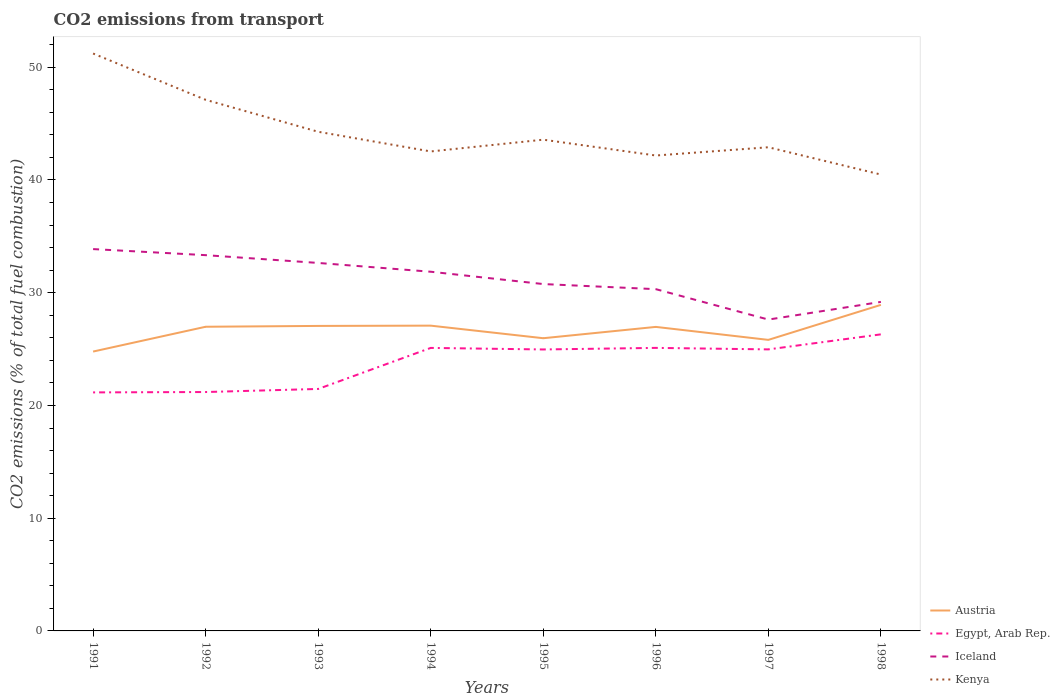Does the line corresponding to Austria intersect with the line corresponding to Iceland?
Offer a terse response. No. Across all years, what is the maximum total CO2 emitted in Austria?
Offer a very short reply. 24.78. In which year was the total CO2 emitted in Egypt, Arab Rep. maximum?
Your response must be concise. 1991. What is the total total CO2 emitted in Kenya in the graph?
Give a very brief answer. -0.73. What is the difference between the highest and the second highest total CO2 emitted in Egypt, Arab Rep.?
Offer a terse response. 5.15. What is the difference between the highest and the lowest total CO2 emitted in Egypt, Arab Rep.?
Ensure brevity in your answer.  5. Are the values on the major ticks of Y-axis written in scientific E-notation?
Your response must be concise. No. Does the graph contain grids?
Your response must be concise. No. Where does the legend appear in the graph?
Your answer should be compact. Bottom right. How many legend labels are there?
Your answer should be very brief. 4. How are the legend labels stacked?
Make the answer very short. Vertical. What is the title of the graph?
Provide a short and direct response. CO2 emissions from transport. What is the label or title of the X-axis?
Give a very brief answer. Years. What is the label or title of the Y-axis?
Your answer should be very brief. CO2 emissions (% of total fuel combustion). What is the CO2 emissions (% of total fuel combustion) in Austria in 1991?
Offer a very short reply. 24.78. What is the CO2 emissions (% of total fuel combustion) in Egypt, Arab Rep. in 1991?
Offer a very short reply. 21.16. What is the CO2 emissions (% of total fuel combustion) of Iceland in 1991?
Your answer should be very brief. 33.87. What is the CO2 emissions (% of total fuel combustion) in Kenya in 1991?
Provide a succinct answer. 51.22. What is the CO2 emissions (% of total fuel combustion) of Austria in 1992?
Your response must be concise. 26.98. What is the CO2 emissions (% of total fuel combustion) in Egypt, Arab Rep. in 1992?
Give a very brief answer. 21.19. What is the CO2 emissions (% of total fuel combustion) of Iceland in 1992?
Your answer should be compact. 33.33. What is the CO2 emissions (% of total fuel combustion) of Kenya in 1992?
Provide a short and direct response. 47.11. What is the CO2 emissions (% of total fuel combustion) of Austria in 1993?
Ensure brevity in your answer.  27.06. What is the CO2 emissions (% of total fuel combustion) in Egypt, Arab Rep. in 1993?
Provide a succinct answer. 21.46. What is the CO2 emissions (% of total fuel combustion) of Iceland in 1993?
Provide a succinct answer. 32.64. What is the CO2 emissions (% of total fuel combustion) of Kenya in 1993?
Give a very brief answer. 44.28. What is the CO2 emissions (% of total fuel combustion) in Austria in 1994?
Offer a terse response. 27.08. What is the CO2 emissions (% of total fuel combustion) in Egypt, Arab Rep. in 1994?
Provide a succinct answer. 25.1. What is the CO2 emissions (% of total fuel combustion) of Iceland in 1994?
Offer a very short reply. 31.86. What is the CO2 emissions (% of total fuel combustion) in Kenya in 1994?
Provide a succinct answer. 42.53. What is the CO2 emissions (% of total fuel combustion) of Austria in 1995?
Offer a terse response. 25.96. What is the CO2 emissions (% of total fuel combustion) of Egypt, Arab Rep. in 1995?
Offer a very short reply. 24.97. What is the CO2 emissions (% of total fuel combustion) of Iceland in 1995?
Give a very brief answer. 30.77. What is the CO2 emissions (% of total fuel combustion) in Kenya in 1995?
Keep it short and to the point. 43.58. What is the CO2 emissions (% of total fuel combustion) in Austria in 1996?
Provide a succinct answer. 26.97. What is the CO2 emissions (% of total fuel combustion) in Egypt, Arab Rep. in 1996?
Offer a terse response. 25.11. What is the CO2 emissions (% of total fuel combustion) in Iceland in 1996?
Provide a short and direct response. 30.32. What is the CO2 emissions (% of total fuel combustion) of Kenya in 1996?
Give a very brief answer. 42.17. What is the CO2 emissions (% of total fuel combustion) in Austria in 1997?
Provide a short and direct response. 25.82. What is the CO2 emissions (% of total fuel combustion) of Egypt, Arab Rep. in 1997?
Make the answer very short. 24.97. What is the CO2 emissions (% of total fuel combustion) in Iceland in 1997?
Ensure brevity in your answer.  27.62. What is the CO2 emissions (% of total fuel combustion) of Kenya in 1997?
Your answer should be very brief. 42.9. What is the CO2 emissions (% of total fuel combustion) of Austria in 1998?
Make the answer very short. 28.92. What is the CO2 emissions (% of total fuel combustion) of Egypt, Arab Rep. in 1998?
Your response must be concise. 26.31. What is the CO2 emissions (% of total fuel combustion) of Iceland in 1998?
Offer a terse response. 29.19. What is the CO2 emissions (% of total fuel combustion) in Kenya in 1998?
Your answer should be compact. 40.48. Across all years, what is the maximum CO2 emissions (% of total fuel combustion) of Austria?
Provide a short and direct response. 28.92. Across all years, what is the maximum CO2 emissions (% of total fuel combustion) of Egypt, Arab Rep.?
Your answer should be compact. 26.31. Across all years, what is the maximum CO2 emissions (% of total fuel combustion) of Iceland?
Give a very brief answer. 33.87. Across all years, what is the maximum CO2 emissions (% of total fuel combustion) of Kenya?
Give a very brief answer. 51.22. Across all years, what is the minimum CO2 emissions (% of total fuel combustion) of Austria?
Make the answer very short. 24.78. Across all years, what is the minimum CO2 emissions (% of total fuel combustion) in Egypt, Arab Rep.?
Your answer should be compact. 21.16. Across all years, what is the minimum CO2 emissions (% of total fuel combustion) in Iceland?
Offer a terse response. 27.62. Across all years, what is the minimum CO2 emissions (% of total fuel combustion) in Kenya?
Offer a very short reply. 40.48. What is the total CO2 emissions (% of total fuel combustion) in Austria in the graph?
Offer a terse response. 213.57. What is the total CO2 emissions (% of total fuel combustion) of Egypt, Arab Rep. in the graph?
Make the answer very short. 190.28. What is the total CO2 emissions (% of total fuel combustion) in Iceland in the graph?
Ensure brevity in your answer.  249.6. What is the total CO2 emissions (% of total fuel combustion) of Kenya in the graph?
Provide a succinct answer. 354.28. What is the difference between the CO2 emissions (% of total fuel combustion) in Austria in 1991 and that in 1992?
Ensure brevity in your answer.  -2.2. What is the difference between the CO2 emissions (% of total fuel combustion) of Egypt, Arab Rep. in 1991 and that in 1992?
Provide a short and direct response. -0.03. What is the difference between the CO2 emissions (% of total fuel combustion) of Iceland in 1991 and that in 1992?
Give a very brief answer. 0.54. What is the difference between the CO2 emissions (% of total fuel combustion) of Kenya in 1991 and that in 1992?
Ensure brevity in your answer.  4.11. What is the difference between the CO2 emissions (% of total fuel combustion) in Austria in 1991 and that in 1993?
Keep it short and to the point. -2.27. What is the difference between the CO2 emissions (% of total fuel combustion) in Egypt, Arab Rep. in 1991 and that in 1993?
Your answer should be compact. -0.31. What is the difference between the CO2 emissions (% of total fuel combustion) in Iceland in 1991 and that in 1993?
Your answer should be very brief. 1.23. What is the difference between the CO2 emissions (% of total fuel combustion) in Kenya in 1991 and that in 1993?
Keep it short and to the point. 6.94. What is the difference between the CO2 emissions (% of total fuel combustion) of Austria in 1991 and that in 1994?
Keep it short and to the point. -2.3. What is the difference between the CO2 emissions (% of total fuel combustion) of Egypt, Arab Rep. in 1991 and that in 1994?
Make the answer very short. -3.95. What is the difference between the CO2 emissions (% of total fuel combustion) of Iceland in 1991 and that in 1994?
Provide a succinct answer. 2.01. What is the difference between the CO2 emissions (% of total fuel combustion) of Kenya in 1991 and that in 1994?
Give a very brief answer. 8.69. What is the difference between the CO2 emissions (% of total fuel combustion) in Austria in 1991 and that in 1995?
Offer a very short reply. -1.18. What is the difference between the CO2 emissions (% of total fuel combustion) in Egypt, Arab Rep. in 1991 and that in 1995?
Give a very brief answer. -3.81. What is the difference between the CO2 emissions (% of total fuel combustion) of Iceland in 1991 and that in 1995?
Ensure brevity in your answer.  3.1. What is the difference between the CO2 emissions (% of total fuel combustion) in Kenya in 1991 and that in 1995?
Give a very brief answer. 7.64. What is the difference between the CO2 emissions (% of total fuel combustion) of Austria in 1991 and that in 1996?
Give a very brief answer. -2.19. What is the difference between the CO2 emissions (% of total fuel combustion) in Egypt, Arab Rep. in 1991 and that in 1996?
Your answer should be compact. -3.95. What is the difference between the CO2 emissions (% of total fuel combustion) in Iceland in 1991 and that in 1996?
Provide a short and direct response. 3.55. What is the difference between the CO2 emissions (% of total fuel combustion) in Kenya in 1991 and that in 1996?
Offer a terse response. 9.05. What is the difference between the CO2 emissions (% of total fuel combustion) of Austria in 1991 and that in 1997?
Your response must be concise. -1.04. What is the difference between the CO2 emissions (% of total fuel combustion) in Egypt, Arab Rep. in 1991 and that in 1997?
Provide a succinct answer. -3.82. What is the difference between the CO2 emissions (% of total fuel combustion) of Iceland in 1991 and that in 1997?
Your answer should be very brief. 6.25. What is the difference between the CO2 emissions (% of total fuel combustion) of Kenya in 1991 and that in 1997?
Your response must be concise. 8.32. What is the difference between the CO2 emissions (% of total fuel combustion) of Austria in 1991 and that in 1998?
Your answer should be very brief. -4.14. What is the difference between the CO2 emissions (% of total fuel combustion) in Egypt, Arab Rep. in 1991 and that in 1998?
Your answer should be compact. -5.15. What is the difference between the CO2 emissions (% of total fuel combustion) of Iceland in 1991 and that in 1998?
Your answer should be compact. 4.68. What is the difference between the CO2 emissions (% of total fuel combustion) of Kenya in 1991 and that in 1998?
Provide a short and direct response. 10.74. What is the difference between the CO2 emissions (% of total fuel combustion) of Austria in 1992 and that in 1993?
Keep it short and to the point. -0.07. What is the difference between the CO2 emissions (% of total fuel combustion) in Egypt, Arab Rep. in 1992 and that in 1993?
Ensure brevity in your answer.  -0.27. What is the difference between the CO2 emissions (% of total fuel combustion) of Iceland in 1992 and that in 1993?
Your response must be concise. 0.69. What is the difference between the CO2 emissions (% of total fuel combustion) in Kenya in 1992 and that in 1993?
Provide a short and direct response. 2.84. What is the difference between the CO2 emissions (% of total fuel combustion) in Austria in 1992 and that in 1994?
Provide a succinct answer. -0.1. What is the difference between the CO2 emissions (% of total fuel combustion) in Egypt, Arab Rep. in 1992 and that in 1994?
Provide a short and direct response. -3.91. What is the difference between the CO2 emissions (% of total fuel combustion) in Iceland in 1992 and that in 1994?
Offer a very short reply. 1.47. What is the difference between the CO2 emissions (% of total fuel combustion) of Kenya in 1992 and that in 1994?
Your answer should be compact. 4.58. What is the difference between the CO2 emissions (% of total fuel combustion) of Austria in 1992 and that in 1995?
Your response must be concise. 1.02. What is the difference between the CO2 emissions (% of total fuel combustion) in Egypt, Arab Rep. in 1992 and that in 1995?
Offer a very short reply. -3.78. What is the difference between the CO2 emissions (% of total fuel combustion) in Iceland in 1992 and that in 1995?
Ensure brevity in your answer.  2.56. What is the difference between the CO2 emissions (% of total fuel combustion) of Kenya in 1992 and that in 1995?
Make the answer very short. 3.54. What is the difference between the CO2 emissions (% of total fuel combustion) in Austria in 1992 and that in 1996?
Keep it short and to the point. 0.01. What is the difference between the CO2 emissions (% of total fuel combustion) in Egypt, Arab Rep. in 1992 and that in 1996?
Your answer should be compact. -3.92. What is the difference between the CO2 emissions (% of total fuel combustion) of Iceland in 1992 and that in 1996?
Provide a succinct answer. 3.02. What is the difference between the CO2 emissions (% of total fuel combustion) in Kenya in 1992 and that in 1996?
Give a very brief answer. 4.94. What is the difference between the CO2 emissions (% of total fuel combustion) of Austria in 1992 and that in 1997?
Provide a short and direct response. 1.16. What is the difference between the CO2 emissions (% of total fuel combustion) of Egypt, Arab Rep. in 1992 and that in 1997?
Ensure brevity in your answer.  -3.78. What is the difference between the CO2 emissions (% of total fuel combustion) of Iceland in 1992 and that in 1997?
Offer a terse response. 5.71. What is the difference between the CO2 emissions (% of total fuel combustion) of Kenya in 1992 and that in 1997?
Give a very brief answer. 4.21. What is the difference between the CO2 emissions (% of total fuel combustion) of Austria in 1992 and that in 1998?
Your response must be concise. -1.94. What is the difference between the CO2 emissions (% of total fuel combustion) of Egypt, Arab Rep. in 1992 and that in 1998?
Offer a very short reply. -5.12. What is the difference between the CO2 emissions (% of total fuel combustion) in Iceland in 1992 and that in 1998?
Offer a very short reply. 4.15. What is the difference between the CO2 emissions (% of total fuel combustion) in Kenya in 1992 and that in 1998?
Keep it short and to the point. 6.63. What is the difference between the CO2 emissions (% of total fuel combustion) of Austria in 1993 and that in 1994?
Your answer should be compact. -0.03. What is the difference between the CO2 emissions (% of total fuel combustion) in Egypt, Arab Rep. in 1993 and that in 1994?
Make the answer very short. -3.64. What is the difference between the CO2 emissions (% of total fuel combustion) in Iceland in 1993 and that in 1994?
Make the answer very short. 0.78. What is the difference between the CO2 emissions (% of total fuel combustion) of Kenya in 1993 and that in 1994?
Provide a short and direct response. 1.74. What is the difference between the CO2 emissions (% of total fuel combustion) in Austria in 1993 and that in 1995?
Keep it short and to the point. 1.09. What is the difference between the CO2 emissions (% of total fuel combustion) in Egypt, Arab Rep. in 1993 and that in 1995?
Offer a very short reply. -3.5. What is the difference between the CO2 emissions (% of total fuel combustion) in Iceland in 1993 and that in 1995?
Keep it short and to the point. 1.87. What is the difference between the CO2 emissions (% of total fuel combustion) of Kenya in 1993 and that in 1995?
Provide a short and direct response. 0.7. What is the difference between the CO2 emissions (% of total fuel combustion) of Austria in 1993 and that in 1996?
Your answer should be very brief. 0.09. What is the difference between the CO2 emissions (% of total fuel combustion) of Egypt, Arab Rep. in 1993 and that in 1996?
Your answer should be very brief. -3.64. What is the difference between the CO2 emissions (% of total fuel combustion) of Iceland in 1993 and that in 1996?
Keep it short and to the point. 2.33. What is the difference between the CO2 emissions (% of total fuel combustion) in Kenya in 1993 and that in 1996?
Offer a very short reply. 2.11. What is the difference between the CO2 emissions (% of total fuel combustion) of Austria in 1993 and that in 1997?
Your response must be concise. 1.24. What is the difference between the CO2 emissions (% of total fuel combustion) in Egypt, Arab Rep. in 1993 and that in 1997?
Make the answer very short. -3.51. What is the difference between the CO2 emissions (% of total fuel combustion) in Iceland in 1993 and that in 1997?
Keep it short and to the point. 5.02. What is the difference between the CO2 emissions (% of total fuel combustion) in Kenya in 1993 and that in 1997?
Give a very brief answer. 1.37. What is the difference between the CO2 emissions (% of total fuel combustion) of Austria in 1993 and that in 1998?
Give a very brief answer. -1.87. What is the difference between the CO2 emissions (% of total fuel combustion) of Egypt, Arab Rep. in 1993 and that in 1998?
Keep it short and to the point. -4.84. What is the difference between the CO2 emissions (% of total fuel combustion) in Iceland in 1993 and that in 1998?
Keep it short and to the point. 3.46. What is the difference between the CO2 emissions (% of total fuel combustion) of Kenya in 1993 and that in 1998?
Ensure brevity in your answer.  3.79. What is the difference between the CO2 emissions (% of total fuel combustion) in Austria in 1994 and that in 1995?
Offer a terse response. 1.12. What is the difference between the CO2 emissions (% of total fuel combustion) of Egypt, Arab Rep. in 1994 and that in 1995?
Ensure brevity in your answer.  0.14. What is the difference between the CO2 emissions (% of total fuel combustion) of Iceland in 1994 and that in 1995?
Make the answer very short. 1.09. What is the difference between the CO2 emissions (% of total fuel combustion) of Kenya in 1994 and that in 1995?
Offer a very short reply. -1.04. What is the difference between the CO2 emissions (% of total fuel combustion) of Austria in 1994 and that in 1996?
Ensure brevity in your answer.  0.11. What is the difference between the CO2 emissions (% of total fuel combustion) in Egypt, Arab Rep. in 1994 and that in 1996?
Your response must be concise. -0. What is the difference between the CO2 emissions (% of total fuel combustion) in Iceland in 1994 and that in 1996?
Keep it short and to the point. 1.55. What is the difference between the CO2 emissions (% of total fuel combustion) of Kenya in 1994 and that in 1996?
Your answer should be compact. 0.36. What is the difference between the CO2 emissions (% of total fuel combustion) in Austria in 1994 and that in 1997?
Provide a short and direct response. 1.26. What is the difference between the CO2 emissions (% of total fuel combustion) in Egypt, Arab Rep. in 1994 and that in 1997?
Ensure brevity in your answer.  0.13. What is the difference between the CO2 emissions (% of total fuel combustion) in Iceland in 1994 and that in 1997?
Ensure brevity in your answer.  4.24. What is the difference between the CO2 emissions (% of total fuel combustion) in Kenya in 1994 and that in 1997?
Your answer should be very brief. -0.37. What is the difference between the CO2 emissions (% of total fuel combustion) in Austria in 1994 and that in 1998?
Make the answer very short. -1.84. What is the difference between the CO2 emissions (% of total fuel combustion) in Egypt, Arab Rep. in 1994 and that in 1998?
Offer a very short reply. -1.2. What is the difference between the CO2 emissions (% of total fuel combustion) of Iceland in 1994 and that in 1998?
Ensure brevity in your answer.  2.68. What is the difference between the CO2 emissions (% of total fuel combustion) in Kenya in 1994 and that in 1998?
Make the answer very short. 2.05. What is the difference between the CO2 emissions (% of total fuel combustion) in Austria in 1995 and that in 1996?
Ensure brevity in your answer.  -1. What is the difference between the CO2 emissions (% of total fuel combustion) in Egypt, Arab Rep. in 1995 and that in 1996?
Ensure brevity in your answer.  -0.14. What is the difference between the CO2 emissions (% of total fuel combustion) of Iceland in 1995 and that in 1996?
Give a very brief answer. 0.45. What is the difference between the CO2 emissions (% of total fuel combustion) in Kenya in 1995 and that in 1996?
Your answer should be compact. 1.4. What is the difference between the CO2 emissions (% of total fuel combustion) in Austria in 1995 and that in 1997?
Offer a very short reply. 0.15. What is the difference between the CO2 emissions (% of total fuel combustion) in Egypt, Arab Rep. in 1995 and that in 1997?
Offer a very short reply. -0.01. What is the difference between the CO2 emissions (% of total fuel combustion) in Iceland in 1995 and that in 1997?
Give a very brief answer. 3.15. What is the difference between the CO2 emissions (% of total fuel combustion) in Kenya in 1995 and that in 1997?
Your answer should be very brief. 0.67. What is the difference between the CO2 emissions (% of total fuel combustion) in Austria in 1995 and that in 1998?
Provide a short and direct response. -2.96. What is the difference between the CO2 emissions (% of total fuel combustion) of Egypt, Arab Rep. in 1995 and that in 1998?
Ensure brevity in your answer.  -1.34. What is the difference between the CO2 emissions (% of total fuel combustion) of Iceland in 1995 and that in 1998?
Ensure brevity in your answer.  1.58. What is the difference between the CO2 emissions (% of total fuel combustion) of Kenya in 1995 and that in 1998?
Give a very brief answer. 3.09. What is the difference between the CO2 emissions (% of total fuel combustion) in Austria in 1996 and that in 1997?
Keep it short and to the point. 1.15. What is the difference between the CO2 emissions (% of total fuel combustion) of Egypt, Arab Rep. in 1996 and that in 1997?
Offer a very short reply. 0.13. What is the difference between the CO2 emissions (% of total fuel combustion) in Iceland in 1996 and that in 1997?
Make the answer very short. 2.7. What is the difference between the CO2 emissions (% of total fuel combustion) in Kenya in 1996 and that in 1997?
Keep it short and to the point. -0.73. What is the difference between the CO2 emissions (% of total fuel combustion) of Austria in 1996 and that in 1998?
Provide a short and direct response. -1.95. What is the difference between the CO2 emissions (% of total fuel combustion) in Egypt, Arab Rep. in 1996 and that in 1998?
Keep it short and to the point. -1.2. What is the difference between the CO2 emissions (% of total fuel combustion) in Iceland in 1996 and that in 1998?
Your answer should be very brief. 1.13. What is the difference between the CO2 emissions (% of total fuel combustion) of Kenya in 1996 and that in 1998?
Your answer should be compact. 1.69. What is the difference between the CO2 emissions (% of total fuel combustion) in Austria in 1997 and that in 1998?
Offer a terse response. -3.11. What is the difference between the CO2 emissions (% of total fuel combustion) in Egypt, Arab Rep. in 1997 and that in 1998?
Make the answer very short. -1.33. What is the difference between the CO2 emissions (% of total fuel combustion) of Iceland in 1997 and that in 1998?
Ensure brevity in your answer.  -1.57. What is the difference between the CO2 emissions (% of total fuel combustion) in Kenya in 1997 and that in 1998?
Ensure brevity in your answer.  2.42. What is the difference between the CO2 emissions (% of total fuel combustion) of Austria in 1991 and the CO2 emissions (% of total fuel combustion) of Egypt, Arab Rep. in 1992?
Provide a succinct answer. 3.59. What is the difference between the CO2 emissions (% of total fuel combustion) of Austria in 1991 and the CO2 emissions (% of total fuel combustion) of Iceland in 1992?
Provide a succinct answer. -8.55. What is the difference between the CO2 emissions (% of total fuel combustion) of Austria in 1991 and the CO2 emissions (% of total fuel combustion) of Kenya in 1992?
Keep it short and to the point. -22.33. What is the difference between the CO2 emissions (% of total fuel combustion) in Egypt, Arab Rep. in 1991 and the CO2 emissions (% of total fuel combustion) in Iceland in 1992?
Your response must be concise. -12.17. What is the difference between the CO2 emissions (% of total fuel combustion) of Egypt, Arab Rep. in 1991 and the CO2 emissions (% of total fuel combustion) of Kenya in 1992?
Offer a terse response. -25.96. What is the difference between the CO2 emissions (% of total fuel combustion) in Iceland in 1991 and the CO2 emissions (% of total fuel combustion) in Kenya in 1992?
Provide a succinct answer. -13.24. What is the difference between the CO2 emissions (% of total fuel combustion) in Austria in 1991 and the CO2 emissions (% of total fuel combustion) in Egypt, Arab Rep. in 1993?
Offer a very short reply. 3.32. What is the difference between the CO2 emissions (% of total fuel combustion) in Austria in 1991 and the CO2 emissions (% of total fuel combustion) in Iceland in 1993?
Ensure brevity in your answer.  -7.86. What is the difference between the CO2 emissions (% of total fuel combustion) in Austria in 1991 and the CO2 emissions (% of total fuel combustion) in Kenya in 1993?
Provide a succinct answer. -19.5. What is the difference between the CO2 emissions (% of total fuel combustion) of Egypt, Arab Rep. in 1991 and the CO2 emissions (% of total fuel combustion) of Iceland in 1993?
Give a very brief answer. -11.48. What is the difference between the CO2 emissions (% of total fuel combustion) of Egypt, Arab Rep. in 1991 and the CO2 emissions (% of total fuel combustion) of Kenya in 1993?
Give a very brief answer. -23.12. What is the difference between the CO2 emissions (% of total fuel combustion) of Iceland in 1991 and the CO2 emissions (% of total fuel combustion) of Kenya in 1993?
Make the answer very short. -10.41. What is the difference between the CO2 emissions (% of total fuel combustion) in Austria in 1991 and the CO2 emissions (% of total fuel combustion) in Egypt, Arab Rep. in 1994?
Give a very brief answer. -0.32. What is the difference between the CO2 emissions (% of total fuel combustion) of Austria in 1991 and the CO2 emissions (% of total fuel combustion) of Iceland in 1994?
Keep it short and to the point. -7.08. What is the difference between the CO2 emissions (% of total fuel combustion) of Austria in 1991 and the CO2 emissions (% of total fuel combustion) of Kenya in 1994?
Your answer should be very brief. -17.75. What is the difference between the CO2 emissions (% of total fuel combustion) in Egypt, Arab Rep. in 1991 and the CO2 emissions (% of total fuel combustion) in Iceland in 1994?
Offer a terse response. -10.7. What is the difference between the CO2 emissions (% of total fuel combustion) in Egypt, Arab Rep. in 1991 and the CO2 emissions (% of total fuel combustion) in Kenya in 1994?
Your answer should be very brief. -21.37. What is the difference between the CO2 emissions (% of total fuel combustion) in Iceland in 1991 and the CO2 emissions (% of total fuel combustion) in Kenya in 1994?
Your answer should be very brief. -8.66. What is the difference between the CO2 emissions (% of total fuel combustion) in Austria in 1991 and the CO2 emissions (% of total fuel combustion) in Egypt, Arab Rep. in 1995?
Your answer should be very brief. -0.19. What is the difference between the CO2 emissions (% of total fuel combustion) in Austria in 1991 and the CO2 emissions (% of total fuel combustion) in Iceland in 1995?
Your answer should be very brief. -5.99. What is the difference between the CO2 emissions (% of total fuel combustion) in Austria in 1991 and the CO2 emissions (% of total fuel combustion) in Kenya in 1995?
Provide a succinct answer. -18.8. What is the difference between the CO2 emissions (% of total fuel combustion) in Egypt, Arab Rep. in 1991 and the CO2 emissions (% of total fuel combustion) in Iceland in 1995?
Provide a succinct answer. -9.61. What is the difference between the CO2 emissions (% of total fuel combustion) in Egypt, Arab Rep. in 1991 and the CO2 emissions (% of total fuel combustion) in Kenya in 1995?
Offer a terse response. -22.42. What is the difference between the CO2 emissions (% of total fuel combustion) of Iceland in 1991 and the CO2 emissions (% of total fuel combustion) of Kenya in 1995?
Offer a very short reply. -9.71. What is the difference between the CO2 emissions (% of total fuel combustion) in Austria in 1991 and the CO2 emissions (% of total fuel combustion) in Egypt, Arab Rep. in 1996?
Provide a succinct answer. -0.33. What is the difference between the CO2 emissions (% of total fuel combustion) in Austria in 1991 and the CO2 emissions (% of total fuel combustion) in Iceland in 1996?
Offer a terse response. -5.54. What is the difference between the CO2 emissions (% of total fuel combustion) of Austria in 1991 and the CO2 emissions (% of total fuel combustion) of Kenya in 1996?
Provide a succinct answer. -17.39. What is the difference between the CO2 emissions (% of total fuel combustion) of Egypt, Arab Rep. in 1991 and the CO2 emissions (% of total fuel combustion) of Iceland in 1996?
Offer a very short reply. -9.16. What is the difference between the CO2 emissions (% of total fuel combustion) of Egypt, Arab Rep. in 1991 and the CO2 emissions (% of total fuel combustion) of Kenya in 1996?
Your answer should be compact. -21.01. What is the difference between the CO2 emissions (% of total fuel combustion) in Iceland in 1991 and the CO2 emissions (% of total fuel combustion) in Kenya in 1996?
Your answer should be compact. -8.3. What is the difference between the CO2 emissions (% of total fuel combustion) of Austria in 1991 and the CO2 emissions (% of total fuel combustion) of Egypt, Arab Rep. in 1997?
Keep it short and to the point. -0.19. What is the difference between the CO2 emissions (% of total fuel combustion) of Austria in 1991 and the CO2 emissions (% of total fuel combustion) of Iceland in 1997?
Your answer should be very brief. -2.84. What is the difference between the CO2 emissions (% of total fuel combustion) in Austria in 1991 and the CO2 emissions (% of total fuel combustion) in Kenya in 1997?
Offer a terse response. -18.12. What is the difference between the CO2 emissions (% of total fuel combustion) in Egypt, Arab Rep. in 1991 and the CO2 emissions (% of total fuel combustion) in Iceland in 1997?
Your answer should be compact. -6.46. What is the difference between the CO2 emissions (% of total fuel combustion) in Egypt, Arab Rep. in 1991 and the CO2 emissions (% of total fuel combustion) in Kenya in 1997?
Your response must be concise. -21.75. What is the difference between the CO2 emissions (% of total fuel combustion) in Iceland in 1991 and the CO2 emissions (% of total fuel combustion) in Kenya in 1997?
Make the answer very short. -9.03. What is the difference between the CO2 emissions (% of total fuel combustion) of Austria in 1991 and the CO2 emissions (% of total fuel combustion) of Egypt, Arab Rep. in 1998?
Keep it short and to the point. -1.53. What is the difference between the CO2 emissions (% of total fuel combustion) in Austria in 1991 and the CO2 emissions (% of total fuel combustion) in Iceland in 1998?
Your response must be concise. -4.41. What is the difference between the CO2 emissions (% of total fuel combustion) of Austria in 1991 and the CO2 emissions (% of total fuel combustion) of Kenya in 1998?
Provide a succinct answer. -15.7. What is the difference between the CO2 emissions (% of total fuel combustion) of Egypt, Arab Rep. in 1991 and the CO2 emissions (% of total fuel combustion) of Iceland in 1998?
Offer a very short reply. -8.03. What is the difference between the CO2 emissions (% of total fuel combustion) of Egypt, Arab Rep. in 1991 and the CO2 emissions (% of total fuel combustion) of Kenya in 1998?
Your answer should be compact. -19.32. What is the difference between the CO2 emissions (% of total fuel combustion) of Iceland in 1991 and the CO2 emissions (% of total fuel combustion) of Kenya in 1998?
Your answer should be very brief. -6.61. What is the difference between the CO2 emissions (% of total fuel combustion) of Austria in 1992 and the CO2 emissions (% of total fuel combustion) of Egypt, Arab Rep. in 1993?
Give a very brief answer. 5.52. What is the difference between the CO2 emissions (% of total fuel combustion) in Austria in 1992 and the CO2 emissions (% of total fuel combustion) in Iceland in 1993?
Provide a succinct answer. -5.66. What is the difference between the CO2 emissions (% of total fuel combustion) of Austria in 1992 and the CO2 emissions (% of total fuel combustion) of Kenya in 1993?
Ensure brevity in your answer.  -17.3. What is the difference between the CO2 emissions (% of total fuel combustion) in Egypt, Arab Rep. in 1992 and the CO2 emissions (% of total fuel combustion) in Iceland in 1993?
Your response must be concise. -11.45. What is the difference between the CO2 emissions (% of total fuel combustion) in Egypt, Arab Rep. in 1992 and the CO2 emissions (% of total fuel combustion) in Kenya in 1993?
Give a very brief answer. -23.09. What is the difference between the CO2 emissions (% of total fuel combustion) in Iceland in 1992 and the CO2 emissions (% of total fuel combustion) in Kenya in 1993?
Give a very brief answer. -10.94. What is the difference between the CO2 emissions (% of total fuel combustion) of Austria in 1992 and the CO2 emissions (% of total fuel combustion) of Egypt, Arab Rep. in 1994?
Make the answer very short. 1.88. What is the difference between the CO2 emissions (% of total fuel combustion) in Austria in 1992 and the CO2 emissions (% of total fuel combustion) in Iceland in 1994?
Provide a short and direct response. -4.88. What is the difference between the CO2 emissions (% of total fuel combustion) in Austria in 1992 and the CO2 emissions (% of total fuel combustion) in Kenya in 1994?
Ensure brevity in your answer.  -15.55. What is the difference between the CO2 emissions (% of total fuel combustion) of Egypt, Arab Rep. in 1992 and the CO2 emissions (% of total fuel combustion) of Iceland in 1994?
Your response must be concise. -10.67. What is the difference between the CO2 emissions (% of total fuel combustion) of Egypt, Arab Rep. in 1992 and the CO2 emissions (% of total fuel combustion) of Kenya in 1994?
Your answer should be very brief. -21.34. What is the difference between the CO2 emissions (% of total fuel combustion) in Iceland in 1992 and the CO2 emissions (% of total fuel combustion) in Kenya in 1994?
Your response must be concise. -9.2. What is the difference between the CO2 emissions (% of total fuel combustion) in Austria in 1992 and the CO2 emissions (% of total fuel combustion) in Egypt, Arab Rep. in 1995?
Offer a terse response. 2.01. What is the difference between the CO2 emissions (% of total fuel combustion) in Austria in 1992 and the CO2 emissions (% of total fuel combustion) in Iceland in 1995?
Your answer should be compact. -3.79. What is the difference between the CO2 emissions (% of total fuel combustion) of Austria in 1992 and the CO2 emissions (% of total fuel combustion) of Kenya in 1995?
Your answer should be very brief. -16.59. What is the difference between the CO2 emissions (% of total fuel combustion) in Egypt, Arab Rep. in 1992 and the CO2 emissions (% of total fuel combustion) in Iceland in 1995?
Ensure brevity in your answer.  -9.58. What is the difference between the CO2 emissions (% of total fuel combustion) in Egypt, Arab Rep. in 1992 and the CO2 emissions (% of total fuel combustion) in Kenya in 1995?
Provide a succinct answer. -22.38. What is the difference between the CO2 emissions (% of total fuel combustion) of Iceland in 1992 and the CO2 emissions (% of total fuel combustion) of Kenya in 1995?
Your answer should be compact. -10.24. What is the difference between the CO2 emissions (% of total fuel combustion) in Austria in 1992 and the CO2 emissions (% of total fuel combustion) in Egypt, Arab Rep. in 1996?
Offer a terse response. 1.87. What is the difference between the CO2 emissions (% of total fuel combustion) in Austria in 1992 and the CO2 emissions (% of total fuel combustion) in Iceland in 1996?
Your answer should be compact. -3.33. What is the difference between the CO2 emissions (% of total fuel combustion) in Austria in 1992 and the CO2 emissions (% of total fuel combustion) in Kenya in 1996?
Give a very brief answer. -15.19. What is the difference between the CO2 emissions (% of total fuel combustion) of Egypt, Arab Rep. in 1992 and the CO2 emissions (% of total fuel combustion) of Iceland in 1996?
Keep it short and to the point. -9.12. What is the difference between the CO2 emissions (% of total fuel combustion) in Egypt, Arab Rep. in 1992 and the CO2 emissions (% of total fuel combustion) in Kenya in 1996?
Ensure brevity in your answer.  -20.98. What is the difference between the CO2 emissions (% of total fuel combustion) in Iceland in 1992 and the CO2 emissions (% of total fuel combustion) in Kenya in 1996?
Your response must be concise. -8.84. What is the difference between the CO2 emissions (% of total fuel combustion) in Austria in 1992 and the CO2 emissions (% of total fuel combustion) in Egypt, Arab Rep. in 1997?
Your answer should be very brief. 2.01. What is the difference between the CO2 emissions (% of total fuel combustion) in Austria in 1992 and the CO2 emissions (% of total fuel combustion) in Iceland in 1997?
Make the answer very short. -0.64. What is the difference between the CO2 emissions (% of total fuel combustion) in Austria in 1992 and the CO2 emissions (% of total fuel combustion) in Kenya in 1997?
Provide a succinct answer. -15.92. What is the difference between the CO2 emissions (% of total fuel combustion) in Egypt, Arab Rep. in 1992 and the CO2 emissions (% of total fuel combustion) in Iceland in 1997?
Ensure brevity in your answer.  -6.43. What is the difference between the CO2 emissions (% of total fuel combustion) in Egypt, Arab Rep. in 1992 and the CO2 emissions (% of total fuel combustion) in Kenya in 1997?
Provide a succinct answer. -21.71. What is the difference between the CO2 emissions (% of total fuel combustion) in Iceland in 1992 and the CO2 emissions (% of total fuel combustion) in Kenya in 1997?
Make the answer very short. -9.57. What is the difference between the CO2 emissions (% of total fuel combustion) of Austria in 1992 and the CO2 emissions (% of total fuel combustion) of Egypt, Arab Rep. in 1998?
Give a very brief answer. 0.67. What is the difference between the CO2 emissions (% of total fuel combustion) of Austria in 1992 and the CO2 emissions (% of total fuel combustion) of Iceland in 1998?
Provide a short and direct response. -2.2. What is the difference between the CO2 emissions (% of total fuel combustion) in Austria in 1992 and the CO2 emissions (% of total fuel combustion) in Kenya in 1998?
Give a very brief answer. -13.5. What is the difference between the CO2 emissions (% of total fuel combustion) in Egypt, Arab Rep. in 1992 and the CO2 emissions (% of total fuel combustion) in Iceland in 1998?
Provide a short and direct response. -7.99. What is the difference between the CO2 emissions (% of total fuel combustion) in Egypt, Arab Rep. in 1992 and the CO2 emissions (% of total fuel combustion) in Kenya in 1998?
Give a very brief answer. -19.29. What is the difference between the CO2 emissions (% of total fuel combustion) of Iceland in 1992 and the CO2 emissions (% of total fuel combustion) of Kenya in 1998?
Your answer should be very brief. -7.15. What is the difference between the CO2 emissions (% of total fuel combustion) in Austria in 1993 and the CO2 emissions (% of total fuel combustion) in Egypt, Arab Rep. in 1994?
Give a very brief answer. 1.95. What is the difference between the CO2 emissions (% of total fuel combustion) of Austria in 1993 and the CO2 emissions (% of total fuel combustion) of Iceland in 1994?
Ensure brevity in your answer.  -4.81. What is the difference between the CO2 emissions (% of total fuel combustion) of Austria in 1993 and the CO2 emissions (% of total fuel combustion) of Kenya in 1994?
Your answer should be very brief. -15.48. What is the difference between the CO2 emissions (% of total fuel combustion) of Egypt, Arab Rep. in 1993 and the CO2 emissions (% of total fuel combustion) of Iceland in 1994?
Your response must be concise. -10.4. What is the difference between the CO2 emissions (% of total fuel combustion) in Egypt, Arab Rep. in 1993 and the CO2 emissions (% of total fuel combustion) in Kenya in 1994?
Offer a very short reply. -21.07. What is the difference between the CO2 emissions (% of total fuel combustion) of Iceland in 1993 and the CO2 emissions (% of total fuel combustion) of Kenya in 1994?
Offer a very short reply. -9.89. What is the difference between the CO2 emissions (% of total fuel combustion) in Austria in 1993 and the CO2 emissions (% of total fuel combustion) in Egypt, Arab Rep. in 1995?
Provide a short and direct response. 2.09. What is the difference between the CO2 emissions (% of total fuel combustion) in Austria in 1993 and the CO2 emissions (% of total fuel combustion) in Iceland in 1995?
Make the answer very short. -3.71. What is the difference between the CO2 emissions (% of total fuel combustion) in Austria in 1993 and the CO2 emissions (% of total fuel combustion) in Kenya in 1995?
Ensure brevity in your answer.  -16.52. What is the difference between the CO2 emissions (% of total fuel combustion) in Egypt, Arab Rep. in 1993 and the CO2 emissions (% of total fuel combustion) in Iceland in 1995?
Provide a succinct answer. -9.31. What is the difference between the CO2 emissions (% of total fuel combustion) of Egypt, Arab Rep. in 1993 and the CO2 emissions (% of total fuel combustion) of Kenya in 1995?
Your response must be concise. -22.11. What is the difference between the CO2 emissions (% of total fuel combustion) in Iceland in 1993 and the CO2 emissions (% of total fuel combustion) in Kenya in 1995?
Give a very brief answer. -10.93. What is the difference between the CO2 emissions (% of total fuel combustion) in Austria in 1993 and the CO2 emissions (% of total fuel combustion) in Egypt, Arab Rep. in 1996?
Your response must be concise. 1.95. What is the difference between the CO2 emissions (% of total fuel combustion) of Austria in 1993 and the CO2 emissions (% of total fuel combustion) of Iceland in 1996?
Make the answer very short. -3.26. What is the difference between the CO2 emissions (% of total fuel combustion) in Austria in 1993 and the CO2 emissions (% of total fuel combustion) in Kenya in 1996?
Ensure brevity in your answer.  -15.12. What is the difference between the CO2 emissions (% of total fuel combustion) of Egypt, Arab Rep. in 1993 and the CO2 emissions (% of total fuel combustion) of Iceland in 1996?
Keep it short and to the point. -8.85. What is the difference between the CO2 emissions (% of total fuel combustion) in Egypt, Arab Rep. in 1993 and the CO2 emissions (% of total fuel combustion) in Kenya in 1996?
Provide a succinct answer. -20.71. What is the difference between the CO2 emissions (% of total fuel combustion) in Iceland in 1993 and the CO2 emissions (% of total fuel combustion) in Kenya in 1996?
Offer a very short reply. -9.53. What is the difference between the CO2 emissions (% of total fuel combustion) of Austria in 1993 and the CO2 emissions (% of total fuel combustion) of Egypt, Arab Rep. in 1997?
Your response must be concise. 2.08. What is the difference between the CO2 emissions (% of total fuel combustion) of Austria in 1993 and the CO2 emissions (% of total fuel combustion) of Iceland in 1997?
Provide a short and direct response. -0.56. What is the difference between the CO2 emissions (% of total fuel combustion) of Austria in 1993 and the CO2 emissions (% of total fuel combustion) of Kenya in 1997?
Give a very brief answer. -15.85. What is the difference between the CO2 emissions (% of total fuel combustion) of Egypt, Arab Rep. in 1993 and the CO2 emissions (% of total fuel combustion) of Iceland in 1997?
Your response must be concise. -6.15. What is the difference between the CO2 emissions (% of total fuel combustion) of Egypt, Arab Rep. in 1993 and the CO2 emissions (% of total fuel combustion) of Kenya in 1997?
Your response must be concise. -21.44. What is the difference between the CO2 emissions (% of total fuel combustion) in Iceland in 1993 and the CO2 emissions (% of total fuel combustion) in Kenya in 1997?
Your response must be concise. -10.26. What is the difference between the CO2 emissions (% of total fuel combustion) in Austria in 1993 and the CO2 emissions (% of total fuel combustion) in Egypt, Arab Rep. in 1998?
Your response must be concise. 0.75. What is the difference between the CO2 emissions (% of total fuel combustion) in Austria in 1993 and the CO2 emissions (% of total fuel combustion) in Iceland in 1998?
Ensure brevity in your answer.  -2.13. What is the difference between the CO2 emissions (% of total fuel combustion) of Austria in 1993 and the CO2 emissions (% of total fuel combustion) of Kenya in 1998?
Offer a terse response. -13.43. What is the difference between the CO2 emissions (% of total fuel combustion) in Egypt, Arab Rep. in 1993 and the CO2 emissions (% of total fuel combustion) in Iceland in 1998?
Provide a short and direct response. -7.72. What is the difference between the CO2 emissions (% of total fuel combustion) in Egypt, Arab Rep. in 1993 and the CO2 emissions (% of total fuel combustion) in Kenya in 1998?
Your answer should be very brief. -19.02. What is the difference between the CO2 emissions (% of total fuel combustion) of Iceland in 1993 and the CO2 emissions (% of total fuel combustion) of Kenya in 1998?
Provide a short and direct response. -7.84. What is the difference between the CO2 emissions (% of total fuel combustion) of Austria in 1994 and the CO2 emissions (% of total fuel combustion) of Egypt, Arab Rep. in 1995?
Your answer should be compact. 2.11. What is the difference between the CO2 emissions (% of total fuel combustion) in Austria in 1994 and the CO2 emissions (% of total fuel combustion) in Iceland in 1995?
Provide a succinct answer. -3.69. What is the difference between the CO2 emissions (% of total fuel combustion) in Austria in 1994 and the CO2 emissions (% of total fuel combustion) in Kenya in 1995?
Your answer should be very brief. -16.5. What is the difference between the CO2 emissions (% of total fuel combustion) in Egypt, Arab Rep. in 1994 and the CO2 emissions (% of total fuel combustion) in Iceland in 1995?
Offer a very short reply. -5.66. What is the difference between the CO2 emissions (% of total fuel combustion) of Egypt, Arab Rep. in 1994 and the CO2 emissions (% of total fuel combustion) of Kenya in 1995?
Offer a very short reply. -18.47. What is the difference between the CO2 emissions (% of total fuel combustion) in Iceland in 1994 and the CO2 emissions (% of total fuel combustion) in Kenya in 1995?
Your response must be concise. -11.71. What is the difference between the CO2 emissions (% of total fuel combustion) in Austria in 1994 and the CO2 emissions (% of total fuel combustion) in Egypt, Arab Rep. in 1996?
Offer a very short reply. 1.97. What is the difference between the CO2 emissions (% of total fuel combustion) in Austria in 1994 and the CO2 emissions (% of total fuel combustion) in Iceland in 1996?
Your response must be concise. -3.24. What is the difference between the CO2 emissions (% of total fuel combustion) of Austria in 1994 and the CO2 emissions (% of total fuel combustion) of Kenya in 1996?
Your response must be concise. -15.09. What is the difference between the CO2 emissions (% of total fuel combustion) of Egypt, Arab Rep. in 1994 and the CO2 emissions (% of total fuel combustion) of Iceland in 1996?
Keep it short and to the point. -5.21. What is the difference between the CO2 emissions (% of total fuel combustion) in Egypt, Arab Rep. in 1994 and the CO2 emissions (% of total fuel combustion) in Kenya in 1996?
Provide a succinct answer. -17.07. What is the difference between the CO2 emissions (% of total fuel combustion) in Iceland in 1994 and the CO2 emissions (% of total fuel combustion) in Kenya in 1996?
Provide a succinct answer. -10.31. What is the difference between the CO2 emissions (% of total fuel combustion) of Austria in 1994 and the CO2 emissions (% of total fuel combustion) of Egypt, Arab Rep. in 1997?
Your response must be concise. 2.11. What is the difference between the CO2 emissions (% of total fuel combustion) in Austria in 1994 and the CO2 emissions (% of total fuel combustion) in Iceland in 1997?
Make the answer very short. -0.54. What is the difference between the CO2 emissions (% of total fuel combustion) in Austria in 1994 and the CO2 emissions (% of total fuel combustion) in Kenya in 1997?
Provide a succinct answer. -15.82. What is the difference between the CO2 emissions (% of total fuel combustion) in Egypt, Arab Rep. in 1994 and the CO2 emissions (% of total fuel combustion) in Iceland in 1997?
Your response must be concise. -2.51. What is the difference between the CO2 emissions (% of total fuel combustion) of Egypt, Arab Rep. in 1994 and the CO2 emissions (% of total fuel combustion) of Kenya in 1997?
Your response must be concise. -17.8. What is the difference between the CO2 emissions (% of total fuel combustion) of Iceland in 1994 and the CO2 emissions (% of total fuel combustion) of Kenya in 1997?
Give a very brief answer. -11.04. What is the difference between the CO2 emissions (% of total fuel combustion) in Austria in 1994 and the CO2 emissions (% of total fuel combustion) in Egypt, Arab Rep. in 1998?
Provide a short and direct response. 0.77. What is the difference between the CO2 emissions (% of total fuel combustion) of Austria in 1994 and the CO2 emissions (% of total fuel combustion) of Iceland in 1998?
Keep it short and to the point. -2.11. What is the difference between the CO2 emissions (% of total fuel combustion) of Austria in 1994 and the CO2 emissions (% of total fuel combustion) of Kenya in 1998?
Provide a short and direct response. -13.4. What is the difference between the CO2 emissions (% of total fuel combustion) in Egypt, Arab Rep. in 1994 and the CO2 emissions (% of total fuel combustion) in Iceland in 1998?
Keep it short and to the point. -4.08. What is the difference between the CO2 emissions (% of total fuel combustion) in Egypt, Arab Rep. in 1994 and the CO2 emissions (% of total fuel combustion) in Kenya in 1998?
Provide a succinct answer. -15.38. What is the difference between the CO2 emissions (% of total fuel combustion) of Iceland in 1994 and the CO2 emissions (% of total fuel combustion) of Kenya in 1998?
Provide a short and direct response. -8.62. What is the difference between the CO2 emissions (% of total fuel combustion) in Austria in 1995 and the CO2 emissions (% of total fuel combustion) in Egypt, Arab Rep. in 1996?
Give a very brief answer. 0.86. What is the difference between the CO2 emissions (% of total fuel combustion) in Austria in 1995 and the CO2 emissions (% of total fuel combustion) in Iceland in 1996?
Ensure brevity in your answer.  -4.35. What is the difference between the CO2 emissions (% of total fuel combustion) in Austria in 1995 and the CO2 emissions (% of total fuel combustion) in Kenya in 1996?
Keep it short and to the point. -16.21. What is the difference between the CO2 emissions (% of total fuel combustion) in Egypt, Arab Rep. in 1995 and the CO2 emissions (% of total fuel combustion) in Iceland in 1996?
Offer a very short reply. -5.35. What is the difference between the CO2 emissions (% of total fuel combustion) of Egypt, Arab Rep. in 1995 and the CO2 emissions (% of total fuel combustion) of Kenya in 1996?
Make the answer very short. -17.21. What is the difference between the CO2 emissions (% of total fuel combustion) of Iceland in 1995 and the CO2 emissions (% of total fuel combustion) of Kenya in 1996?
Provide a short and direct response. -11.4. What is the difference between the CO2 emissions (% of total fuel combustion) in Austria in 1995 and the CO2 emissions (% of total fuel combustion) in Egypt, Arab Rep. in 1997?
Ensure brevity in your answer.  0.99. What is the difference between the CO2 emissions (% of total fuel combustion) of Austria in 1995 and the CO2 emissions (% of total fuel combustion) of Iceland in 1997?
Offer a terse response. -1.65. What is the difference between the CO2 emissions (% of total fuel combustion) of Austria in 1995 and the CO2 emissions (% of total fuel combustion) of Kenya in 1997?
Offer a terse response. -16.94. What is the difference between the CO2 emissions (% of total fuel combustion) of Egypt, Arab Rep. in 1995 and the CO2 emissions (% of total fuel combustion) of Iceland in 1997?
Provide a succinct answer. -2.65. What is the difference between the CO2 emissions (% of total fuel combustion) of Egypt, Arab Rep. in 1995 and the CO2 emissions (% of total fuel combustion) of Kenya in 1997?
Provide a short and direct response. -17.94. What is the difference between the CO2 emissions (% of total fuel combustion) of Iceland in 1995 and the CO2 emissions (% of total fuel combustion) of Kenya in 1997?
Make the answer very short. -12.14. What is the difference between the CO2 emissions (% of total fuel combustion) in Austria in 1995 and the CO2 emissions (% of total fuel combustion) in Egypt, Arab Rep. in 1998?
Offer a terse response. -0.34. What is the difference between the CO2 emissions (% of total fuel combustion) of Austria in 1995 and the CO2 emissions (% of total fuel combustion) of Iceland in 1998?
Provide a short and direct response. -3.22. What is the difference between the CO2 emissions (% of total fuel combustion) of Austria in 1995 and the CO2 emissions (% of total fuel combustion) of Kenya in 1998?
Offer a very short reply. -14.52. What is the difference between the CO2 emissions (% of total fuel combustion) of Egypt, Arab Rep. in 1995 and the CO2 emissions (% of total fuel combustion) of Iceland in 1998?
Keep it short and to the point. -4.22. What is the difference between the CO2 emissions (% of total fuel combustion) of Egypt, Arab Rep. in 1995 and the CO2 emissions (% of total fuel combustion) of Kenya in 1998?
Offer a very short reply. -15.52. What is the difference between the CO2 emissions (% of total fuel combustion) of Iceland in 1995 and the CO2 emissions (% of total fuel combustion) of Kenya in 1998?
Offer a terse response. -9.71. What is the difference between the CO2 emissions (% of total fuel combustion) in Austria in 1996 and the CO2 emissions (% of total fuel combustion) in Egypt, Arab Rep. in 1997?
Your answer should be compact. 2. What is the difference between the CO2 emissions (% of total fuel combustion) of Austria in 1996 and the CO2 emissions (% of total fuel combustion) of Iceland in 1997?
Your answer should be compact. -0.65. What is the difference between the CO2 emissions (% of total fuel combustion) in Austria in 1996 and the CO2 emissions (% of total fuel combustion) in Kenya in 1997?
Keep it short and to the point. -15.94. What is the difference between the CO2 emissions (% of total fuel combustion) in Egypt, Arab Rep. in 1996 and the CO2 emissions (% of total fuel combustion) in Iceland in 1997?
Provide a succinct answer. -2.51. What is the difference between the CO2 emissions (% of total fuel combustion) of Egypt, Arab Rep. in 1996 and the CO2 emissions (% of total fuel combustion) of Kenya in 1997?
Offer a terse response. -17.8. What is the difference between the CO2 emissions (% of total fuel combustion) in Iceland in 1996 and the CO2 emissions (% of total fuel combustion) in Kenya in 1997?
Give a very brief answer. -12.59. What is the difference between the CO2 emissions (% of total fuel combustion) in Austria in 1996 and the CO2 emissions (% of total fuel combustion) in Egypt, Arab Rep. in 1998?
Keep it short and to the point. 0.66. What is the difference between the CO2 emissions (% of total fuel combustion) of Austria in 1996 and the CO2 emissions (% of total fuel combustion) of Iceland in 1998?
Offer a very short reply. -2.22. What is the difference between the CO2 emissions (% of total fuel combustion) of Austria in 1996 and the CO2 emissions (% of total fuel combustion) of Kenya in 1998?
Provide a short and direct response. -13.51. What is the difference between the CO2 emissions (% of total fuel combustion) in Egypt, Arab Rep. in 1996 and the CO2 emissions (% of total fuel combustion) in Iceland in 1998?
Your answer should be very brief. -4.08. What is the difference between the CO2 emissions (% of total fuel combustion) of Egypt, Arab Rep. in 1996 and the CO2 emissions (% of total fuel combustion) of Kenya in 1998?
Your answer should be compact. -15.38. What is the difference between the CO2 emissions (% of total fuel combustion) in Iceland in 1996 and the CO2 emissions (% of total fuel combustion) in Kenya in 1998?
Offer a terse response. -10.17. What is the difference between the CO2 emissions (% of total fuel combustion) in Austria in 1997 and the CO2 emissions (% of total fuel combustion) in Egypt, Arab Rep. in 1998?
Offer a terse response. -0.49. What is the difference between the CO2 emissions (% of total fuel combustion) in Austria in 1997 and the CO2 emissions (% of total fuel combustion) in Iceland in 1998?
Your answer should be compact. -3.37. What is the difference between the CO2 emissions (% of total fuel combustion) of Austria in 1997 and the CO2 emissions (% of total fuel combustion) of Kenya in 1998?
Offer a terse response. -14.67. What is the difference between the CO2 emissions (% of total fuel combustion) of Egypt, Arab Rep. in 1997 and the CO2 emissions (% of total fuel combustion) of Iceland in 1998?
Offer a very short reply. -4.21. What is the difference between the CO2 emissions (% of total fuel combustion) of Egypt, Arab Rep. in 1997 and the CO2 emissions (% of total fuel combustion) of Kenya in 1998?
Make the answer very short. -15.51. What is the difference between the CO2 emissions (% of total fuel combustion) in Iceland in 1997 and the CO2 emissions (% of total fuel combustion) in Kenya in 1998?
Keep it short and to the point. -12.86. What is the average CO2 emissions (% of total fuel combustion) in Austria per year?
Provide a succinct answer. 26.7. What is the average CO2 emissions (% of total fuel combustion) of Egypt, Arab Rep. per year?
Your answer should be compact. 23.78. What is the average CO2 emissions (% of total fuel combustion) of Iceland per year?
Offer a very short reply. 31.2. What is the average CO2 emissions (% of total fuel combustion) of Kenya per year?
Provide a succinct answer. 44.29. In the year 1991, what is the difference between the CO2 emissions (% of total fuel combustion) in Austria and CO2 emissions (% of total fuel combustion) in Egypt, Arab Rep.?
Your answer should be very brief. 3.62. In the year 1991, what is the difference between the CO2 emissions (% of total fuel combustion) of Austria and CO2 emissions (% of total fuel combustion) of Iceland?
Provide a short and direct response. -9.09. In the year 1991, what is the difference between the CO2 emissions (% of total fuel combustion) of Austria and CO2 emissions (% of total fuel combustion) of Kenya?
Provide a succinct answer. -26.44. In the year 1991, what is the difference between the CO2 emissions (% of total fuel combustion) of Egypt, Arab Rep. and CO2 emissions (% of total fuel combustion) of Iceland?
Your answer should be very brief. -12.71. In the year 1991, what is the difference between the CO2 emissions (% of total fuel combustion) in Egypt, Arab Rep. and CO2 emissions (% of total fuel combustion) in Kenya?
Provide a succinct answer. -30.06. In the year 1991, what is the difference between the CO2 emissions (% of total fuel combustion) of Iceland and CO2 emissions (% of total fuel combustion) of Kenya?
Offer a very short reply. -17.35. In the year 1992, what is the difference between the CO2 emissions (% of total fuel combustion) of Austria and CO2 emissions (% of total fuel combustion) of Egypt, Arab Rep.?
Provide a succinct answer. 5.79. In the year 1992, what is the difference between the CO2 emissions (% of total fuel combustion) in Austria and CO2 emissions (% of total fuel combustion) in Iceland?
Provide a succinct answer. -6.35. In the year 1992, what is the difference between the CO2 emissions (% of total fuel combustion) in Austria and CO2 emissions (% of total fuel combustion) in Kenya?
Offer a terse response. -20.13. In the year 1992, what is the difference between the CO2 emissions (% of total fuel combustion) of Egypt, Arab Rep. and CO2 emissions (% of total fuel combustion) of Iceland?
Your answer should be compact. -12.14. In the year 1992, what is the difference between the CO2 emissions (% of total fuel combustion) of Egypt, Arab Rep. and CO2 emissions (% of total fuel combustion) of Kenya?
Give a very brief answer. -25.92. In the year 1992, what is the difference between the CO2 emissions (% of total fuel combustion) in Iceland and CO2 emissions (% of total fuel combustion) in Kenya?
Your response must be concise. -13.78. In the year 1993, what is the difference between the CO2 emissions (% of total fuel combustion) in Austria and CO2 emissions (% of total fuel combustion) in Egypt, Arab Rep.?
Make the answer very short. 5.59. In the year 1993, what is the difference between the CO2 emissions (% of total fuel combustion) in Austria and CO2 emissions (% of total fuel combustion) in Iceland?
Give a very brief answer. -5.59. In the year 1993, what is the difference between the CO2 emissions (% of total fuel combustion) of Austria and CO2 emissions (% of total fuel combustion) of Kenya?
Keep it short and to the point. -17.22. In the year 1993, what is the difference between the CO2 emissions (% of total fuel combustion) in Egypt, Arab Rep. and CO2 emissions (% of total fuel combustion) in Iceland?
Your response must be concise. -11.18. In the year 1993, what is the difference between the CO2 emissions (% of total fuel combustion) of Egypt, Arab Rep. and CO2 emissions (% of total fuel combustion) of Kenya?
Your answer should be compact. -22.81. In the year 1993, what is the difference between the CO2 emissions (% of total fuel combustion) of Iceland and CO2 emissions (% of total fuel combustion) of Kenya?
Provide a succinct answer. -11.64. In the year 1994, what is the difference between the CO2 emissions (% of total fuel combustion) in Austria and CO2 emissions (% of total fuel combustion) in Egypt, Arab Rep.?
Provide a short and direct response. 1.98. In the year 1994, what is the difference between the CO2 emissions (% of total fuel combustion) of Austria and CO2 emissions (% of total fuel combustion) of Iceland?
Offer a terse response. -4.78. In the year 1994, what is the difference between the CO2 emissions (% of total fuel combustion) of Austria and CO2 emissions (% of total fuel combustion) of Kenya?
Your response must be concise. -15.45. In the year 1994, what is the difference between the CO2 emissions (% of total fuel combustion) in Egypt, Arab Rep. and CO2 emissions (% of total fuel combustion) in Iceland?
Ensure brevity in your answer.  -6.76. In the year 1994, what is the difference between the CO2 emissions (% of total fuel combustion) of Egypt, Arab Rep. and CO2 emissions (% of total fuel combustion) of Kenya?
Make the answer very short. -17.43. In the year 1994, what is the difference between the CO2 emissions (% of total fuel combustion) of Iceland and CO2 emissions (% of total fuel combustion) of Kenya?
Your answer should be very brief. -10.67. In the year 1995, what is the difference between the CO2 emissions (% of total fuel combustion) of Austria and CO2 emissions (% of total fuel combustion) of Egypt, Arab Rep.?
Keep it short and to the point. 1. In the year 1995, what is the difference between the CO2 emissions (% of total fuel combustion) in Austria and CO2 emissions (% of total fuel combustion) in Iceland?
Provide a short and direct response. -4.8. In the year 1995, what is the difference between the CO2 emissions (% of total fuel combustion) of Austria and CO2 emissions (% of total fuel combustion) of Kenya?
Offer a terse response. -17.61. In the year 1995, what is the difference between the CO2 emissions (% of total fuel combustion) of Egypt, Arab Rep. and CO2 emissions (% of total fuel combustion) of Iceland?
Your response must be concise. -5.8. In the year 1995, what is the difference between the CO2 emissions (% of total fuel combustion) of Egypt, Arab Rep. and CO2 emissions (% of total fuel combustion) of Kenya?
Make the answer very short. -18.61. In the year 1995, what is the difference between the CO2 emissions (% of total fuel combustion) of Iceland and CO2 emissions (% of total fuel combustion) of Kenya?
Your response must be concise. -12.81. In the year 1996, what is the difference between the CO2 emissions (% of total fuel combustion) in Austria and CO2 emissions (% of total fuel combustion) in Egypt, Arab Rep.?
Offer a terse response. 1.86. In the year 1996, what is the difference between the CO2 emissions (% of total fuel combustion) in Austria and CO2 emissions (% of total fuel combustion) in Iceland?
Provide a succinct answer. -3.35. In the year 1996, what is the difference between the CO2 emissions (% of total fuel combustion) in Austria and CO2 emissions (% of total fuel combustion) in Kenya?
Make the answer very short. -15.2. In the year 1996, what is the difference between the CO2 emissions (% of total fuel combustion) in Egypt, Arab Rep. and CO2 emissions (% of total fuel combustion) in Iceland?
Your answer should be compact. -5.21. In the year 1996, what is the difference between the CO2 emissions (% of total fuel combustion) in Egypt, Arab Rep. and CO2 emissions (% of total fuel combustion) in Kenya?
Provide a short and direct response. -17.07. In the year 1996, what is the difference between the CO2 emissions (% of total fuel combustion) in Iceland and CO2 emissions (% of total fuel combustion) in Kenya?
Your response must be concise. -11.86. In the year 1997, what is the difference between the CO2 emissions (% of total fuel combustion) of Austria and CO2 emissions (% of total fuel combustion) of Egypt, Arab Rep.?
Offer a terse response. 0.84. In the year 1997, what is the difference between the CO2 emissions (% of total fuel combustion) in Austria and CO2 emissions (% of total fuel combustion) in Iceland?
Make the answer very short. -1.8. In the year 1997, what is the difference between the CO2 emissions (% of total fuel combustion) of Austria and CO2 emissions (% of total fuel combustion) of Kenya?
Give a very brief answer. -17.09. In the year 1997, what is the difference between the CO2 emissions (% of total fuel combustion) of Egypt, Arab Rep. and CO2 emissions (% of total fuel combustion) of Iceland?
Your response must be concise. -2.65. In the year 1997, what is the difference between the CO2 emissions (% of total fuel combustion) in Egypt, Arab Rep. and CO2 emissions (% of total fuel combustion) in Kenya?
Offer a terse response. -17.93. In the year 1997, what is the difference between the CO2 emissions (% of total fuel combustion) of Iceland and CO2 emissions (% of total fuel combustion) of Kenya?
Make the answer very short. -15.29. In the year 1998, what is the difference between the CO2 emissions (% of total fuel combustion) of Austria and CO2 emissions (% of total fuel combustion) of Egypt, Arab Rep.?
Make the answer very short. 2.62. In the year 1998, what is the difference between the CO2 emissions (% of total fuel combustion) in Austria and CO2 emissions (% of total fuel combustion) in Iceland?
Keep it short and to the point. -0.26. In the year 1998, what is the difference between the CO2 emissions (% of total fuel combustion) of Austria and CO2 emissions (% of total fuel combustion) of Kenya?
Provide a succinct answer. -11.56. In the year 1998, what is the difference between the CO2 emissions (% of total fuel combustion) of Egypt, Arab Rep. and CO2 emissions (% of total fuel combustion) of Iceland?
Offer a very short reply. -2.88. In the year 1998, what is the difference between the CO2 emissions (% of total fuel combustion) in Egypt, Arab Rep. and CO2 emissions (% of total fuel combustion) in Kenya?
Offer a terse response. -14.18. In the year 1998, what is the difference between the CO2 emissions (% of total fuel combustion) in Iceland and CO2 emissions (% of total fuel combustion) in Kenya?
Offer a terse response. -11.3. What is the ratio of the CO2 emissions (% of total fuel combustion) of Austria in 1991 to that in 1992?
Your answer should be very brief. 0.92. What is the ratio of the CO2 emissions (% of total fuel combustion) in Iceland in 1991 to that in 1992?
Your response must be concise. 1.02. What is the ratio of the CO2 emissions (% of total fuel combustion) of Kenya in 1991 to that in 1992?
Offer a very short reply. 1.09. What is the ratio of the CO2 emissions (% of total fuel combustion) in Austria in 1991 to that in 1993?
Make the answer very short. 0.92. What is the ratio of the CO2 emissions (% of total fuel combustion) in Egypt, Arab Rep. in 1991 to that in 1993?
Offer a very short reply. 0.99. What is the ratio of the CO2 emissions (% of total fuel combustion) in Iceland in 1991 to that in 1993?
Offer a very short reply. 1.04. What is the ratio of the CO2 emissions (% of total fuel combustion) in Kenya in 1991 to that in 1993?
Your answer should be compact. 1.16. What is the ratio of the CO2 emissions (% of total fuel combustion) of Austria in 1991 to that in 1994?
Your answer should be compact. 0.92. What is the ratio of the CO2 emissions (% of total fuel combustion) in Egypt, Arab Rep. in 1991 to that in 1994?
Offer a terse response. 0.84. What is the ratio of the CO2 emissions (% of total fuel combustion) of Iceland in 1991 to that in 1994?
Provide a short and direct response. 1.06. What is the ratio of the CO2 emissions (% of total fuel combustion) of Kenya in 1991 to that in 1994?
Provide a short and direct response. 1.2. What is the ratio of the CO2 emissions (% of total fuel combustion) of Austria in 1991 to that in 1995?
Your response must be concise. 0.95. What is the ratio of the CO2 emissions (% of total fuel combustion) in Egypt, Arab Rep. in 1991 to that in 1995?
Provide a short and direct response. 0.85. What is the ratio of the CO2 emissions (% of total fuel combustion) of Iceland in 1991 to that in 1995?
Give a very brief answer. 1.1. What is the ratio of the CO2 emissions (% of total fuel combustion) in Kenya in 1991 to that in 1995?
Offer a very short reply. 1.18. What is the ratio of the CO2 emissions (% of total fuel combustion) of Austria in 1991 to that in 1996?
Your answer should be compact. 0.92. What is the ratio of the CO2 emissions (% of total fuel combustion) in Egypt, Arab Rep. in 1991 to that in 1996?
Offer a very short reply. 0.84. What is the ratio of the CO2 emissions (% of total fuel combustion) of Iceland in 1991 to that in 1996?
Your answer should be very brief. 1.12. What is the ratio of the CO2 emissions (% of total fuel combustion) of Kenya in 1991 to that in 1996?
Your answer should be very brief. 1.21. What is the ratio of the CO2 emissions (% of total fuel combustion) of Austria in 1991 to that in 1997?
Offer a very short reply. 0.96. What is the ratio of the CO2 emissions (% of total fuel combustion) in Egypt, Arab Rep. in 1991 to that in 1997?
Your answer should be very brief. 0.85. What is the ratio of the CO2 emissions (% of total fuel combustion) of Iceland in 1991 to that in 1997?
Offer a terse response. 1.23. What is the ratio of the CO2 emissions (% of total fuel combustion) in Kenya in 1991 to that in 1997?
Keep it short and to the point. 1.19. What is the ratio of the CO2 emissions (% of total fuel combustion) in Austria in 1991 to that in 1998?
Provide a succinct answer. 0.86. What is the ratio of the CO2 emissions (% of total fuel combustion) in Egypt, Arab Rep. in 1991 to that in 1998?
Make the answer very short. 0.8. What is the ratio of the CO2 emissions (% of total fuel combustion) in Iceland in 1991 to that in 1998?
Ensure brevity in your answer.  1.16. What is the ratio of the CO2 emissions (% of total fuel combustion) of Kenya in 1991 to that in 1998?
Your answer should be very brief. 1.27. What is the ratio of the CO2 emissions (% of total fuel combustion) in Austria in 1992 to that in 1993?
Ensure brevity in your answer.  1. What is the ratio of the CO2 emissions (% of total fuel combustion) of Egypt, Arab Rep. in 1992 to that in 1993?
Your answer should be compact. 0.99. What is the ratio of the CO2 emissions (% of total fuel combustion) of Iceland in 1992 to that in 1993?
Provide a short and direct response. 1.02. What is the ratio of the CO2 emissions (% of total fuel combustion) in Kenya in 1992 to that in 1993?
Your answer should be compact. 1.06. What is the ratio of the CO2 emissions (% of total fuel combustion) in Austria in 1992 to that in 1994?
Offer a terse response. 1. What is the ratio of the CO2 emissions (% of total fuel combustion) of Egypt, Arab Rep. in 1992 to that in 1994?
Ensure brevity in your answer.  0.84. What is the ratio of the CO2 emissions (% of total fuel combustion) in Iceland in 1992 to that in 1994?
Ensure brevity in your answer.  1.05. What is the ratio of the CO2 emissions (% of total fuel combustion) of Kenya in 1992 to that in 1994?
Your answer should be very brief. 1.11. What is the ratio of the CO2 emissions (% of total fuel combustion) of Austria in 1992 to that in 1995?
Your answer should be compact. 1.04. What is the ratio of the CO2 emissions (% of total fuel combustion) in Egypt, Arab Rep. in 1992 to that in 1995?
Provide a succinct answer. 0.85. What is the ratio of the CO2 emissions (% of total fuel combustion) of Iceland in 1992 to that in 1995?
Keep it short and to the point. 1.08. What is the ratio of the CO2 emissions (% of total fuel combustion) in Kenya in 1992 to that in 1995?
Your answer should be very brief. 1.08. What is the ratio of the CO2 emissions (% of total fuel combustion) in Egypt, Arab Rep. in 1992 to that in 1996?
Provide a short and direct response. 0.84. What is the ratio of the CO2 emissions (% of total fuel combustion) in Iceland in 1992 to that in 1996?
Your answer should be very brief. 1.1. What is the ratio of the CO2 emissions (% of total fuel combustion) in Kenya in 1992 to that in 1996?
Your response must be concise. 1.12. What is the ratio of the CO2 emissions (% of total fuel combustion) of Austria in 1992 to that in 1997?
Offer a terse response. 1.05. What is the ratio of the CO2 emissions (% of total fuel combustion) in Egypt, Arab Rep. in 1992 to that in 1997?
Ensure brevity in your answer.  0.85. What is the ratio of the CO2 emissions (% of total fuel combustion) in Iceland in 1992 to that in 1997?
Make the answer very short. 1.21. What is the ratio of the CO2 emissions (% of total fuel combustion) of Kenya in 1992 to that in 1997?
Your answer should be very brief. 1.1. What is the ratio of the CO2 emissions (% of total fuel combustion) in Austria in 1992 to that in 1998?
Give a very brief answer. 0.93. What is the ratio of the CO2 emissions (% of total fuel combustion) in Egypt, Arab Rep. in 1992 to that in 1998?
Provide a short and direct response. 0.81. What is the ratio of the CO2 emissions (% of total fuel combustion) in Iceland in 1992 to that in 1998?
Ensure brevity in your answer.  1.14. What is the ratio of the CO2 emissions (% of total fuel combustion) in Kenya in 1992 to that in 1998?
Make the answer very short. 1.16. What is the ratio of the CO2 emissions (% of total fuel combustion) of Austria in 1993 to that in 1994?
Ensure brevity in your answer.  1. What is the ratio of the CO2 emissions (% of total fuel combustion) of Egypt, Arab Rep. in 1993 to that in 1994?
Your answer should be compact. 0.85. What is the ratio of the CO2 emissions (% of total fuel combustion) in Iceland in 1993 to that in 1994?
Make the answer very short. 1.02. What is the ratio of the CO2 emissions (% of total fuel combustion) in Kenya in 1993 to that in 1994?
Your answer should be compact. 1.04. What is the ratio of the CO2 emissions (% of total fuel combustion) in Austria in 1993 to that in 1995?
Offer a terse response. 1.04. What is the ratio of the CO2 emissions (% of total fuel combustion) in Egypt, Arab Rep. in 1993 to that in 1995?
Make the answer very short. 0.86. What is the ratio of the CO2 emissions (% of total fuel combustion) in Iceland in 1993 to that in 1995?
Offer a terse response. 1.06. What is the ratio of the CO2 emissions (% of total fuel combustion) in Kenya in 1993 to that in 1995?
Your answer should be very brief. 1.02. What is the ratio of the CO2 emissions (% of total fuel combustion) in Austria in 1993 to that in 1996?
Give a very brief answer. 1. What is the ratio of the CO2 emissions (% of total fuel combustion) of Egypt, Arab Rep. in 1993 to that in 1996?
Offer a terse response. 0.85. What is the ratio of the CO2 emissions (% of total fuel combustion) in Iceland in 1993 to that in 1996?
Ensure brevity in your answer.  1.08. What is the ratio of the CO2 emissions (% of total fuel combustion) of Kenya in 1993 to that in 1996?
Ensure brevity in your answer.  1.05. What is the ratio of the CO2 emissions (% of total fuel combustion) in Austria in 1993 to that in 1997?
Your response must be concise. 1.05. What is the ratio of the CO2 emissions (% of total fuel combustion) of Egypt, Arab Rep. in 1993 to that in 1997?
Make the answer very short. 0.86. What is the ratio of the CO2 emissions (% of total fuel combustion) of Iceland in 1993 to that in 1997?
Offer a terse response. 1.18. What is the ratio of the CO2 emissions (% of total fuel combustion) of Kenya in 1993 to that in 1997?
Provide a succinct answer. 1.03. What is the ratio of the CO2 emissions (% of total fuel combustion) in Austria in 1993 to that in 1998?
Make the answer very short. 0.94. What is the ratio of the CO2 emissions (% of total fuel combustion) of Egypt, Arab Rep. in 1993 to that in 1998?
Provide a succinct answer. 0.82. What is the ratio of the CO2 emissions (% of total fuel combustion) of Iceland in 1993 to that in 1998?
Your answer should be compact. 1.12. What is the ratio of the CO2 emissions (% of total fuel combustion) in Kenya in 1993 to that in 1998?
Provide a short and direct response. 1.09. What is the ratio of the CO2 emissions (% of total fuel combustion) of Austria in 1994 to that in 1995?
Your response must be concise. 1.04. What is the ratio of the CO2 emissions (% of total fuel combustion) of Iceland in 1994 to that in 1995?
Ensure brevity in your answer.  1.04. What is the ratio of the CO2 emissions (% of total fuel combustion) of Kenya in 1994 to that in 1995?
Offer a very short reply. 0.98. What is the ratio of the CO2 emissions (% of total fuel combustion) in Egypt, Arab Rep. in 1994 to that in 1996?
Ensure brevity in your answer.  1. What is the ratio of the CO2 emissions (% of total fuel combustion) of Iceland in 1994 to that in 1996?
Make the answer very short. 1.05. What is the ratio of the CO2 emissions (% of total fuel combustion) of Kenya in 1994 to that in 1996?
Keep it short and to the point. 1.01. What is the ratio of the CO2 emissions (% of total fuel combustion) of Austria in 1994 to that in 1997?
Your response must be concise. 1.05. What is the ratio of the CO2 emissions (% of total fuel combustion) of Egypt, Arab Rep. in 1994 to that in 1997?
Keep it short and to the point. 1.01. What is the ratio of the CO2 emissions (% of total fuel combustion) in Iceland in 1994 to that in 1997?
Provide a succinct answer. 1.15. What is the ratio of the CO2 emissions (% of total fuel combustion) of Kenya in 1994 to that in 1997?
Offer a terse response. 0.99. What is the ratio of the CO2 emissions (% of total fuel combustion) in Austria in 1994 to that in 1998?
Your answer should be very brief. 0.94. What is the ratio of the CO2 emissions (% of total fuel combustion) in Egypt, Arab Rep. in 1994 to that in 1998?
Give a very brief answer. 0.95. What is the ratio of the CO2 emissions (% of total fuel combustion) of Iceland in 1994 to that in 1998?
Provide a succinct answer. 1.09. What is the ratio of the CO2 emissions (% of total fuel combustion) in Kenya in 1994 to that in 1998?
Provide a succinct answer. 1.05. What is the ratio of the CO2 emissions (% of total fuel combustion) of Austria in 1995 to that in 1996?
Offer a very short reply. 0.96. What is the ratio of the CO2 emissions (% of total fuel combustion) of Iceland in 1995 to that in 1996?
Your answer should be very brief. 1.01. What is the ratio of the CO2 emissions (% of total fuel combustion) of Austria in 1995 to that in 1997?
Make the answer very short. 1.01. What is the ratio of the CO2 emissions (% of total fuel combustion) in Iceland in 1995 to that in 1997?
Make the answer very short. 1.11. What is the ratio of the CO2 emissions (% of total fuel combustion) in Kenya in 1995 to that in 1997?
Provide a short and direct response. 1.02. What is the ratio of the CO2 emissions (% of total fuel combustion) of Austria in 1995 to that in 1998?
Offer a very short reply. 0.9. What is the ratio of the CO2 emissions (% of total fuel combustion) of Egypt, Arab Rep. in 1995 to that in 1998?
Your response must be concise. 0.95. What is the ratio of the CO2 emissions (% of total fuel combustion) in Iceland in 1995 to that in 1998?
Offer a very short reply. 1.05. What is the ratio of the CO2 emissions (% of total fuel combustion) of Kenya in 1995 to that in 1998?
Give a very brief answer. 1.08. What is the ratio of the CO2 emissions (% of total fuel combustion) of Austria in 1996 to that in 1997?
Ensure brevity in your answer.  1.04. What is the ratio of the CO2 emissions (% of total fuel combustion) in Iceland in 1996 to that in 1997?
Offer a terse response. 1.1. What is the ratio of the CO2 emissions (% of total fuel combustion) in Kenya in 1996 to that in 1997?
Give a very brief answer. 0.98. What is the ratio of the CO2 emissions (% of total fuel combustion) in Austria in 1996 to that in 1998?
Your answer should be very brief. 0.93. What is the ratio of the CO2 emissions (% of total fuel combustion) of Egypt, Arab Rep. in 1996 to that in 1998?
Your answer should be very brief. 0.95. What is the ratio of the CO2 emissions (% of total fuel combustion) in Iceland in 1996 to that in 1998?
Ensure brevity in your answer.  1.04. What is the ratio of the CO2 emissions (% of total fuel combustion) in Kenya in 1996 to that in 1998?
Give a very brief answer. 1.04. What is the ratio of the CO2 emissions (% of total fuel combustion) in Austria in 1997 to that in 1998?
Make the answer very short. 0.89. What is the ratio of the CO2 emissions (% of total fuel combustion) of Egypt, Arab Rep. in 1997 to that in 1998?
Your response must be concise. 0.95. What is the ratio of the CO2 emissions (% of total fuel combustion) of Iceland in 1997 to that in 1998?
Make the answer very short. 0.95. What is the ratio of the CO2 emissions (% of total fuel combustion) in Kenya in 1997 to that in 1998?
Your answer should be compact. 1.06. What is the difference between the highest and the second highest CO2 emissions (% of total fuel combustion) in Austria?
Make the answer very short. 1.84. What is the difference between the highest and the second highest CO2 emissions (% of total fuel combustion) of Egypt, Arab Rep.?
Provide a succinct answer. 1.2. What is the difference between the highest and the second highest CO2 emissions (% of total fuel combustion) in Iceland?
Keep it short and to the point. 0.54. What is the difference between the highest and the second highest CO2 emissions (% of total fuel combustion) in Kenya?
Your answer should be very brief. 4.11. What is the difference between the highest and the lowest CO2 emissions (% of total fuel combustion) of Austria?
Your answer should be compact. 4.14. What is the difference between the highest and the lowest CO2 emissions (% of total fuel combustion) in Egypt, Arab Rep.?
Provide a succinct answer. 5.15. What is the difference between the highest and the lowest CO2 emissions (% of total fuel combustion) in Iceland?
Ensure brevity in your answer.  6.25. What is the difference between the highest and the lowest CO2 emissions (% of total fuel combustion) of Kenya?
Your answer should be compact. 10.74. 